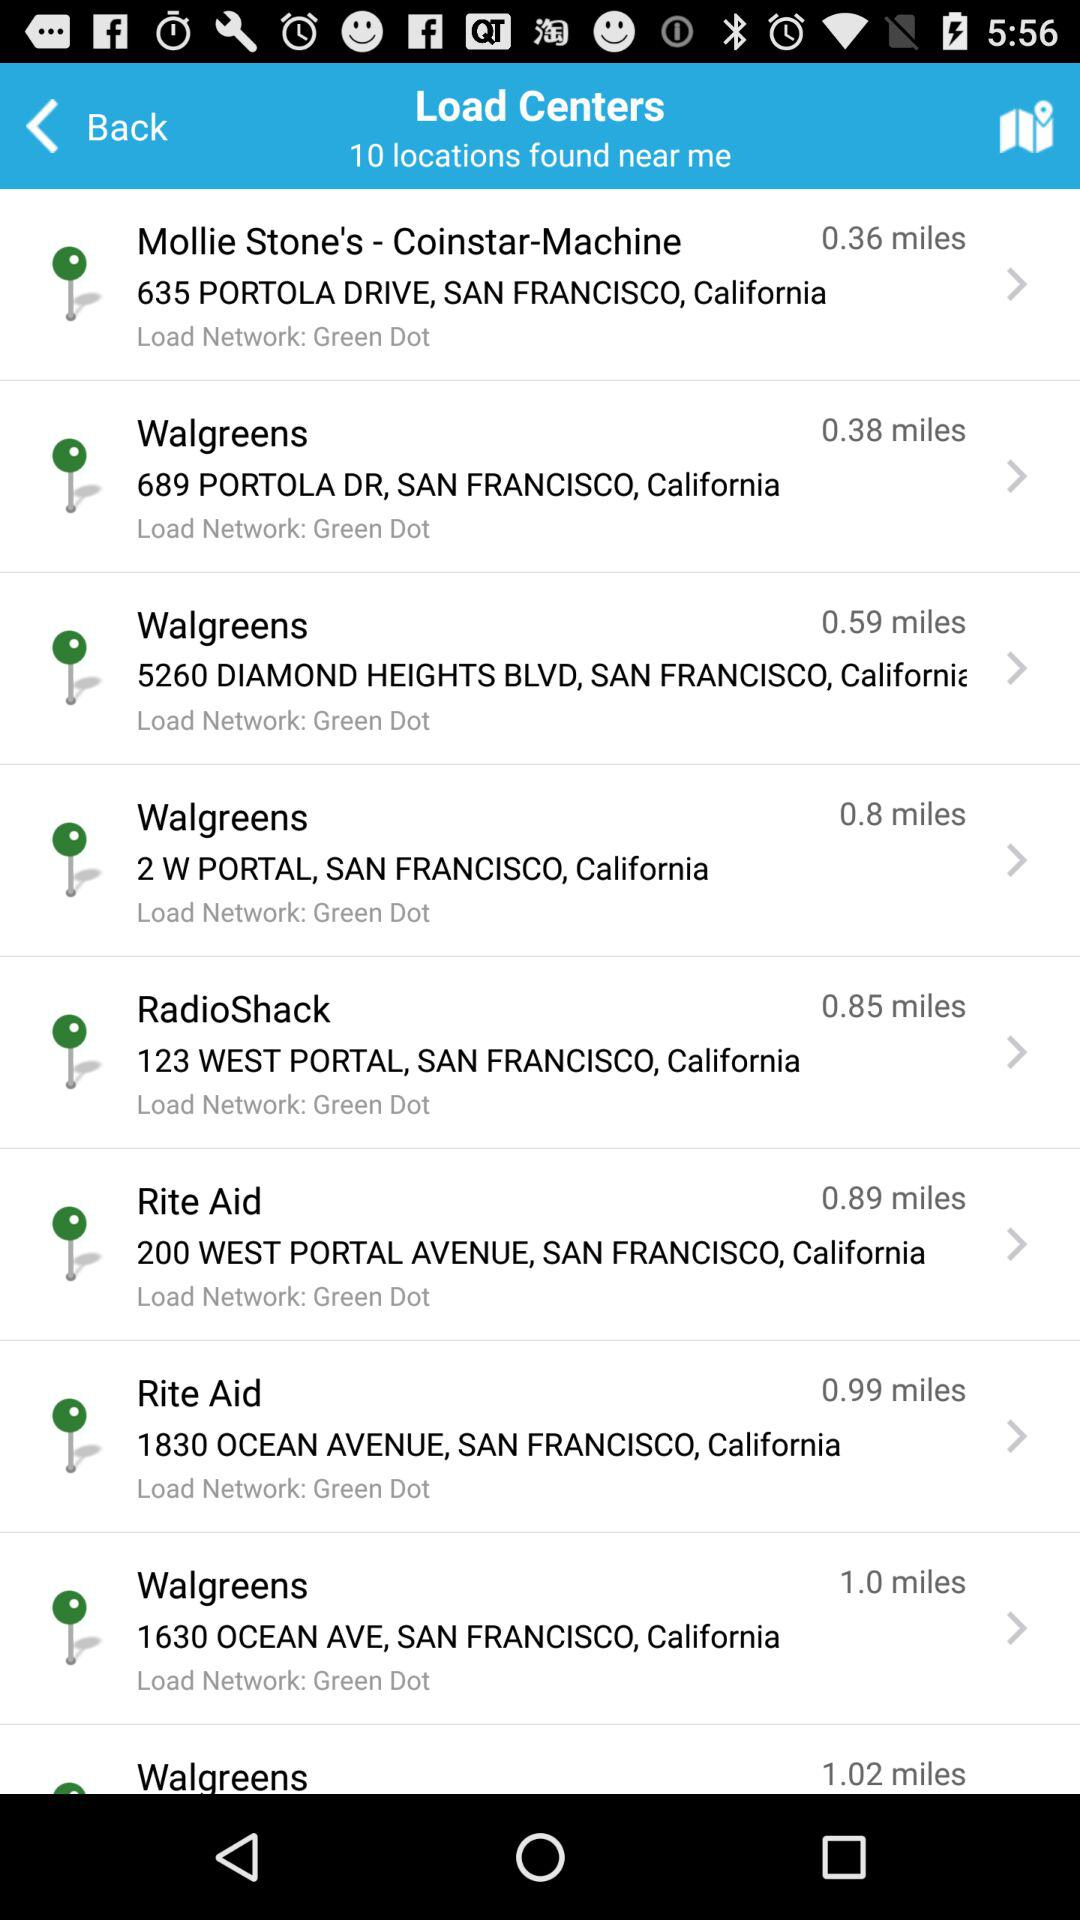How far is "Rite Aid" from the source? "Rite Aid" is 0.89 miles away. 